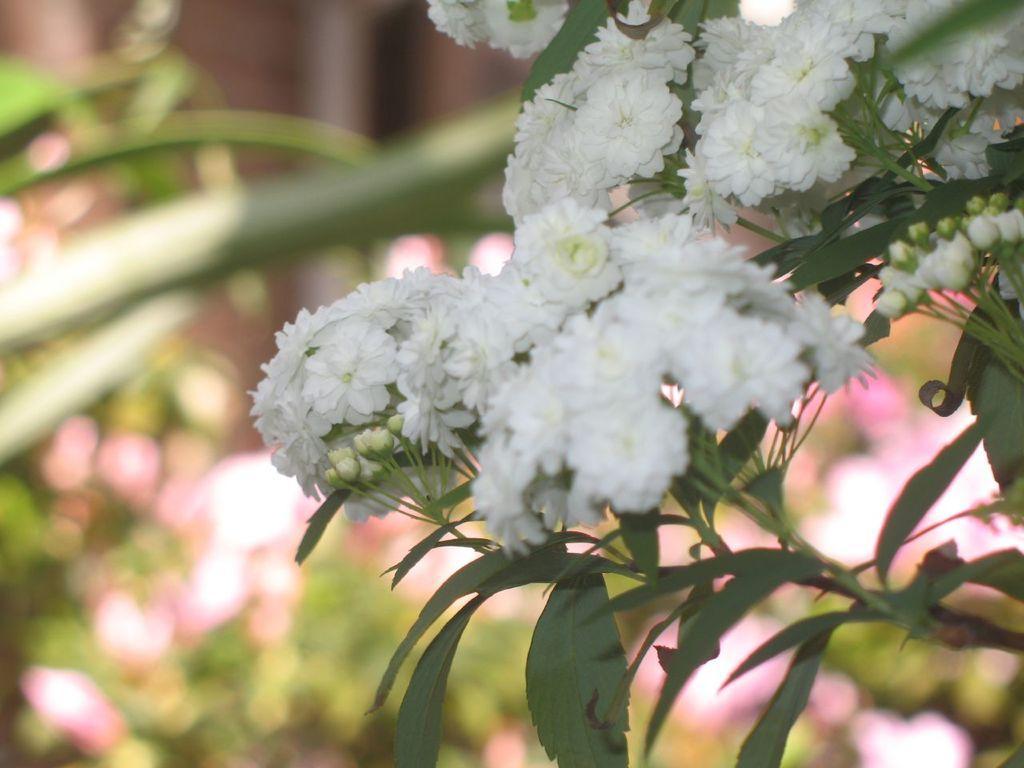Can you describe this image briefly? In this image there are small white color flowers to the plant. In the background there are plants with different color flowers. 